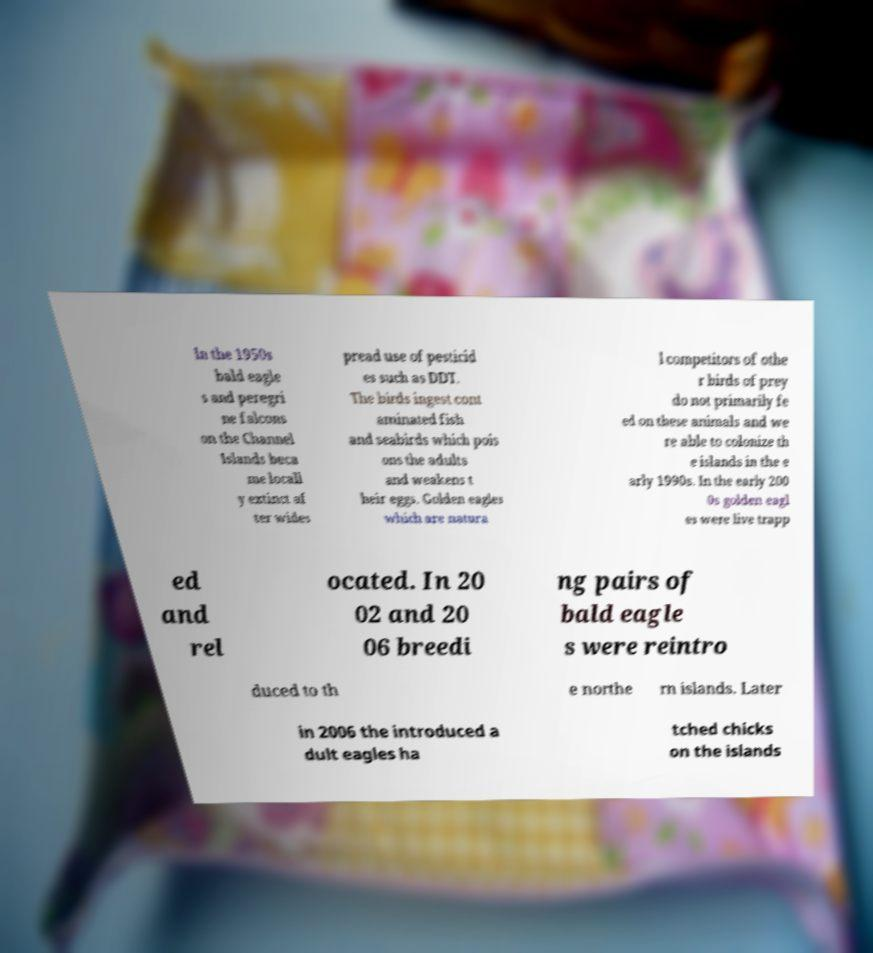Can you read and provide the text displayed in the image?This photo seems to have some interesting text. Can you extract and type it out for me? In the 1950s bald eagle s and peregri ne falcons on the Channel Islands beca me locall y extinct af ter wides pread use of pesticid es such as DDT. The birds ingest cont aminated fish and seabirds which pois ons the adults and weakens t heir eggs. Golden eagles which are natura l competitors of othe r birds of prey do not primarily fe ed on these animals and we re able to colonize th e islands in the e arly 1990s. In the early 200 0s golden eagl es were live trapp ed and rel ocated. In 20 02 and 20 06 breedi ng pairs of bald eagle s were reintro duced to th e northe rn islands. Later in 2006 the introduced a dult eagles ha tched chicks on the islands 